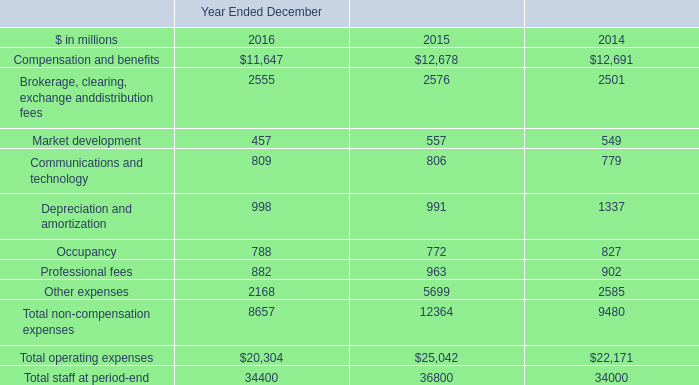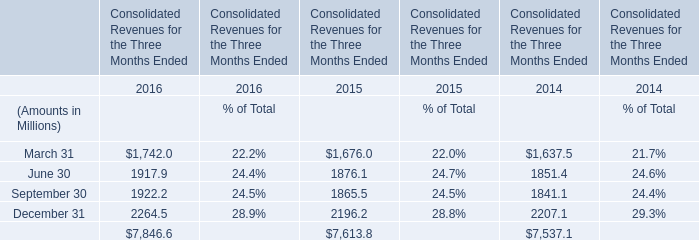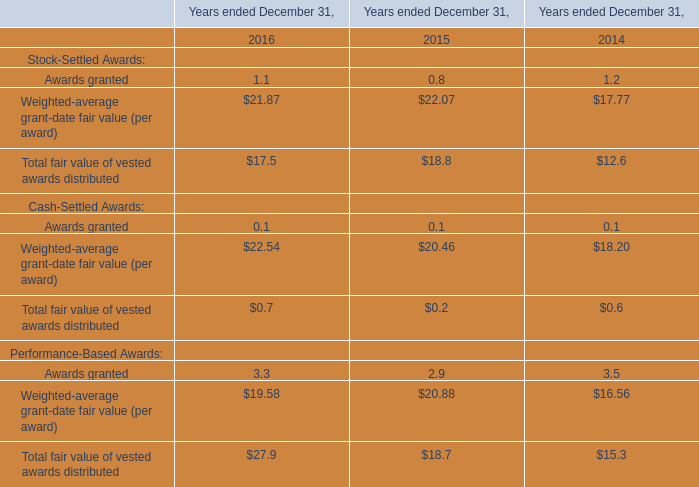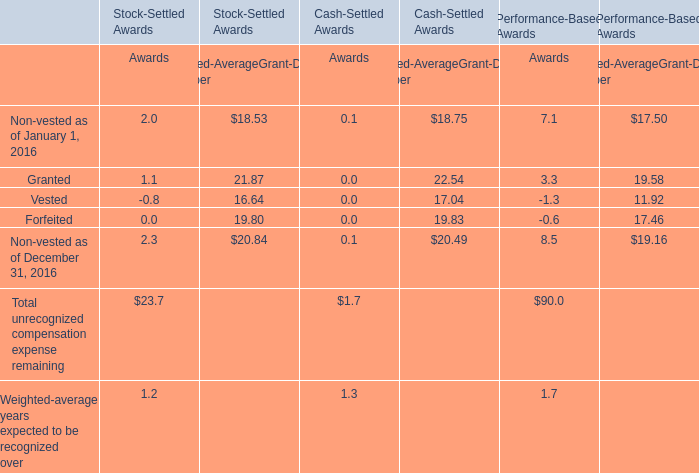What is the sum of Awards granted in 2016 and 2015? 
Computations: (1.1 + 0.8)
Answer: 1.9. 